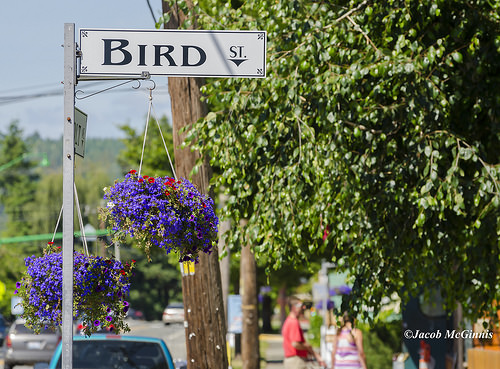<image>
Can you confirm if the flower is in front of the tree? Yes. The flower is positioned in front of the tree, appearing closer to the camera viewpoint. Is there a line to the left of the leaf? Yes. From this viewpoint, the line is positioned to the left side relative to the leaf. 